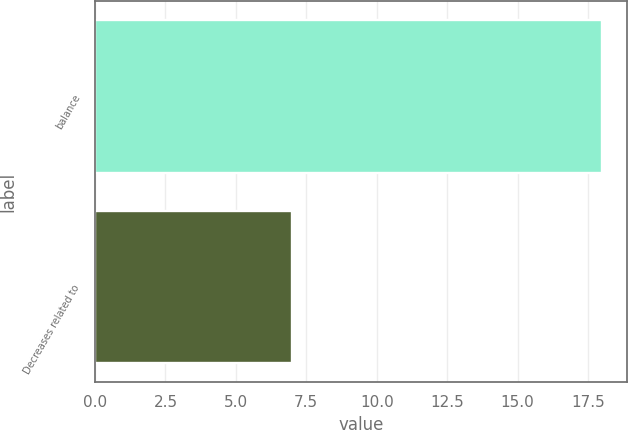<chart> <loc_0><loc_0><loc_500><loc_500><bar_chart><fcel>balance<fcel>Decreases related to<nl><fcel>18<fcel>7<nl></chart> 